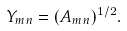<formula> <loc_0><loc_0><loc_500><loc_500>Y _ { m n } = ( A _ { m n } ) ^ { 1 / 2 } .</formula> 